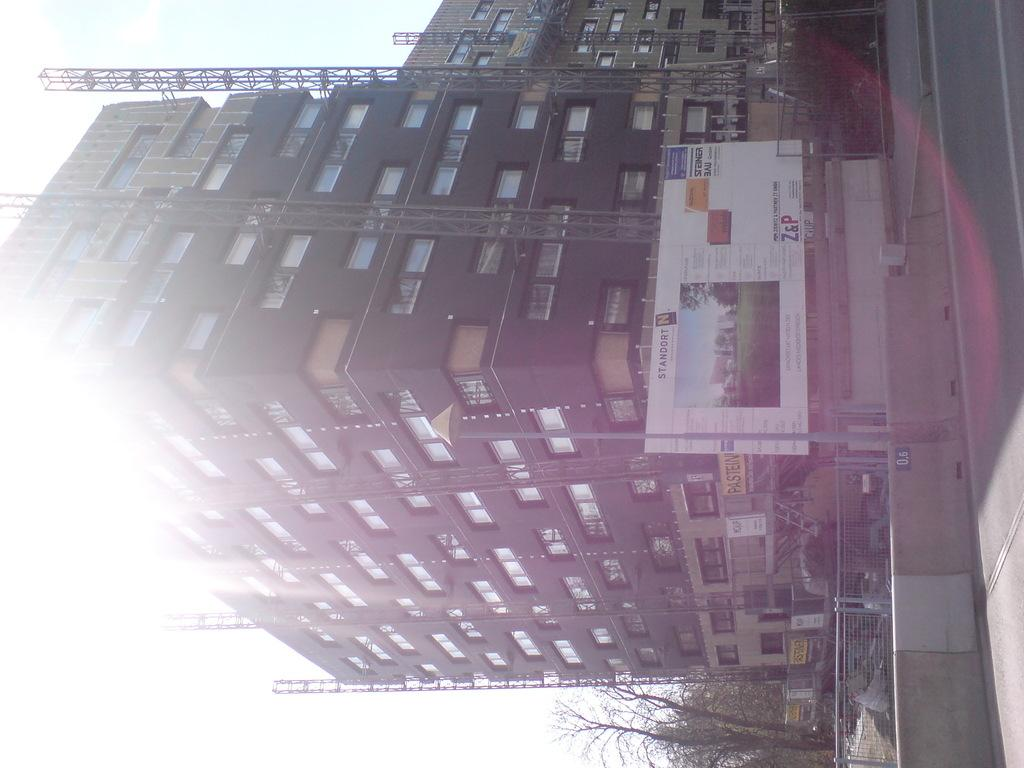What type of structures can be seen in the image? There are buildings in the image. What material is used for the rods in the image? The rods in the image are made of metal. What type of vegetation is present in the image? There are trees in the image. What type of barrier can be seen in the image? There are fences in the image. What type of signage is present in the image? There are hoardings in the image. Can you tell me how many snails are crawling on the buildings in the image? There are no snails present in the image. What type of breath can be seen coming from the trees in the image? There is no breath visible in the image, as it is a still image and not a video. 